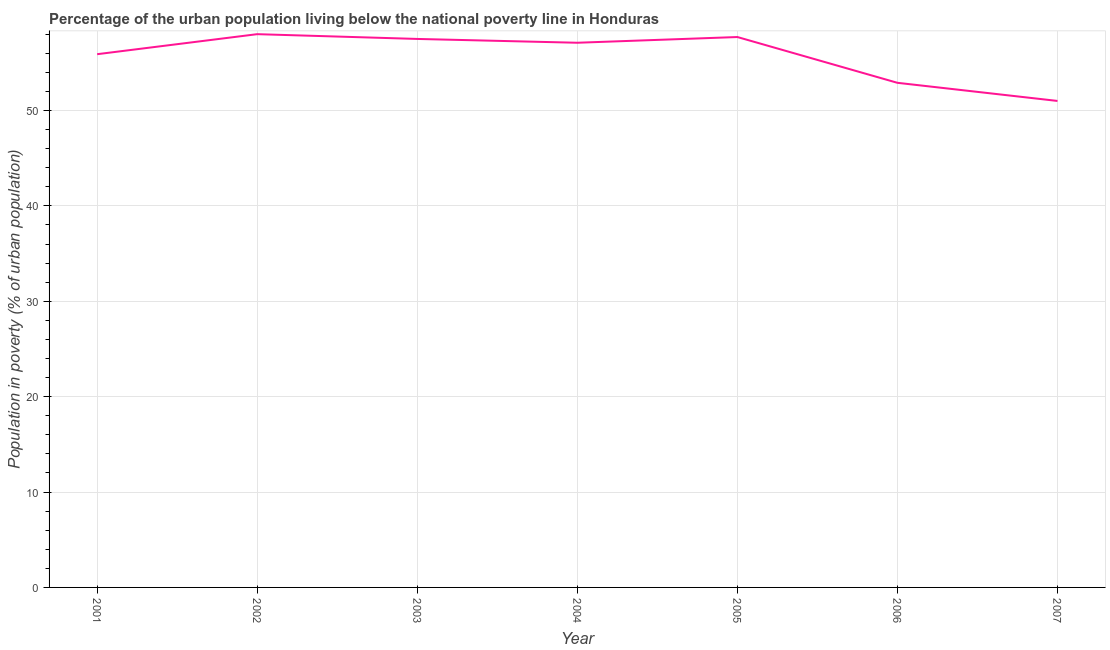What is the percentage of urban population living below poverty line in 2007?
Your answer should be compact. 51. In which year was the percentage of urban population living below poverty line maximum?
Your answer should be compact. 2002. What is the sum of the percentage of urban population living below poverty line?
Your answer should be very brief. 390.1. What is the difference between the percentage of urban population living below poverty line in 2004 and 2005?
Provide a succinct answer. -0.6. What is the average percentage of urban population living below poverty line per year?
Make the answer very short. 55.73. What is the median percentage of urban population living below poverty line?
Your response must be concise. 57.1. In how many years, is the percentage of urban population living below poverty line greater than 38 %?
Your response must be concise. 7. Do a majority of the years between 2003 and 2007 (inclusive) have percentage of urban population living below poverty line greater than 8 %?
Give a very brief answer. Yes. What is the ratio of the percentage of urban population living below poverty line in 2001 to that in 2007?
Give a very brief answer. 1.1. Is the difference between the percentage of urban population living below poverty line in 2001 and 2004 greater than the difference between any two years?
Make the answer very short. No. What is the difference between the highest and the second highest percentage of urban population living below poverty line?
Your answer should be compact. 0.3. In how many years, is the percentage of urban population living below poverty line greater than the average percentage of urban population living below poverty line taken over all years?
Make the answer very short. 5. Does the percentage of urban population living below poverty line monotonically increase over the years?
Your response must be concise. No. How many lines are there?
Your answer should be compact. 1. How many years are there in the graph?
Your response must be concise. 7. Are the values on the major ticks of Y-axis written in scientific E-notation?
Provide a succinct answer. No. What is the title of the graph?
Your response must be concise. Percentage of the urban population living below the national poverty line in Honduras. What is the label or title of the Y-axis?
Your response must be concise. Population in poverty (% of urban population). What is the Population in poverty (% of urban population) of 2001?
Your response must be concise. 55.9. What is the Population in poverty (% of urban population) in 2002?
Your answer should be compact. 58. What is the Population in poverty (% of urban population) in 2003?
Offer a terse response. 57.5. What is the Population in poverty (% of urban population) in 2004?
Offer a very short reply. 57.1. What is the Population in poverty (% of urban population) of 2005?
Ensure brevity in your answer.  57.7. What is the Population in poverty (% of urban population) in 2006?
Offer a very short reply. 52.9. What is the Population in poverty (% of urban population) of 2007?
Your answer should be very brief. 51. What is the difference between the Population in poverty (% of urban population) in 2001 and 2002?
Ensure brevity in your answer.  -2.1. What is the difference between the Population in poverty (% of urban population) in 2001 and 2003?
Your answer should be compact. -1.6. What is the difference between the Population in poverty (% of urban population) in 2001 and 2006?
Your answer should be very brief. 3. What is the difference between the Population in poverty (% of urban population) in 2001 and 2007?
Give a very brief answer. 4.9. What is the difference between the Population in poverty (% of urban population) in 2002 and 2003?
Offer a terse response. 0.5. What is the difference between the Population in poverty (% of urban population) in 2002 and 2004?
Offer a very short reply. 0.9. What is the difference between the Population in poverty (% of urban population) in 2003 and 2005?
Give a very brief answer. -0.2. What is the difference between the Population in poverty (% of urban population) in 2004 and 2006?
Your answer should be compact. 4.2. What is the difference between the Population in poverty (% of urban population) in 2004 and 2007?
Your answer should be very brief. 6.1. What is the difference between the Population in poverty (% of urban population) in 2005 and 2007?
Offer a very short reply. 6.7. What is the difference between the Population in poverty (% of urban population) in 2006 and 2007?
Your answer should be compact. 1.9. What is the ratio of the Population in poverty (% of urban population) in 2001 to that in 2004?
Your answer should be compact. 0.98. What is the ratio of the Population in poverty (% of urban population) in 2001 to that in 2005?
Your answer should be very brief. 0.97. What is the ratio of the Population in poverty (% of urban population) in 2001 to that in 2006?
Your response must be concise. 1.06. What is the ratio of the Population in poverty (% of urban population) in 2001 to that in 2007?
Offer a terse response. 1.1. What is the ratio of the Population in poverty (% of urban population) in 2002 to that in 2003?
Ensure brevity in your answer.  1.01. What is the ratio of the Population in poverty (% of urban population) in 2002 to that in 2005?
Provide a short and direct response. 1. What is the ratio of the Population in poverty (% of urban population) in 2002 to that in 2006?
Make the answer very short. 1.1. What is the ratio of the Population in poverty (% of urban population) in 2002 to that in 2007?
Provide a succinct answer. 1.14. What is the ratio of the Population in poverty (% of urban population) in 2003 to that in 2004?
Your response must be concise. 1.01. What is the ratio of the Population in poverty (% of urban population) in 2003 to that in 2005?
Offer a terse response. 1. What is the ratio of the Population in poverty (% of urban population) in 2003 to that in 2006?
Offer a terse response. 1.09. What is the ratio of the Population in poverty (% of urban population) in 2003 to that in 2007?
Provide a succinct answer. 1.13. What is the ratio of the Population in poverty (% of urban population) in 2004 to that in 2006?
Ensure brevity in your answer.  1.08. What is the ratio of the Population in poverty (% of urban population) in 2004 to that in 2007?
Your answer should be very brief. 1.12. What is the ratio of the Population in poverty (% of urban population) in 2005 to that in 2006?
Offer a very short reply. 1.09. What is the ratio of the Population in poverty (% of urban population) in 2005 to that in 2007?
Provide a succinct answer. 1.13. What is the ratio of the Population in poverty (% of urban population) in 2006 to that in 2007?
Make the answer very short. 1.04. 